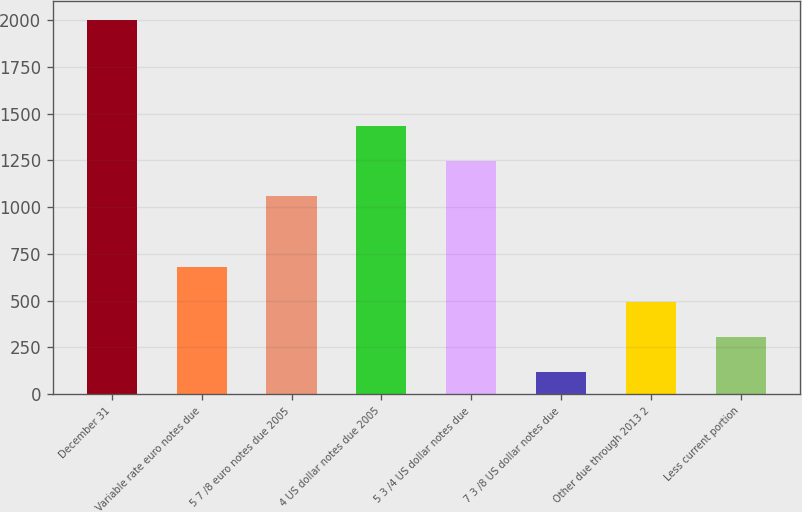<chart> <loc_0><loc_0><loc_500><loc_500><bar_chart><fcel>December 31<fcel>Variable rate euro notes due<fcel>5 7 /8 euro notes due 2005<fcel>4 US dollar notes due 2005<fcel>5 3 /4 US dollar notes due<fcel>7 3 /8 US dollar notes due<fcel>Other due through 2013 2<fcel>Less current portion<nl><fcel>2002<fcel>681.8<fcel>1059<fcel>1436.2<fcel>1247.6<fcel>116<fcel>493.2<fcel>304.6<nl></chart> 